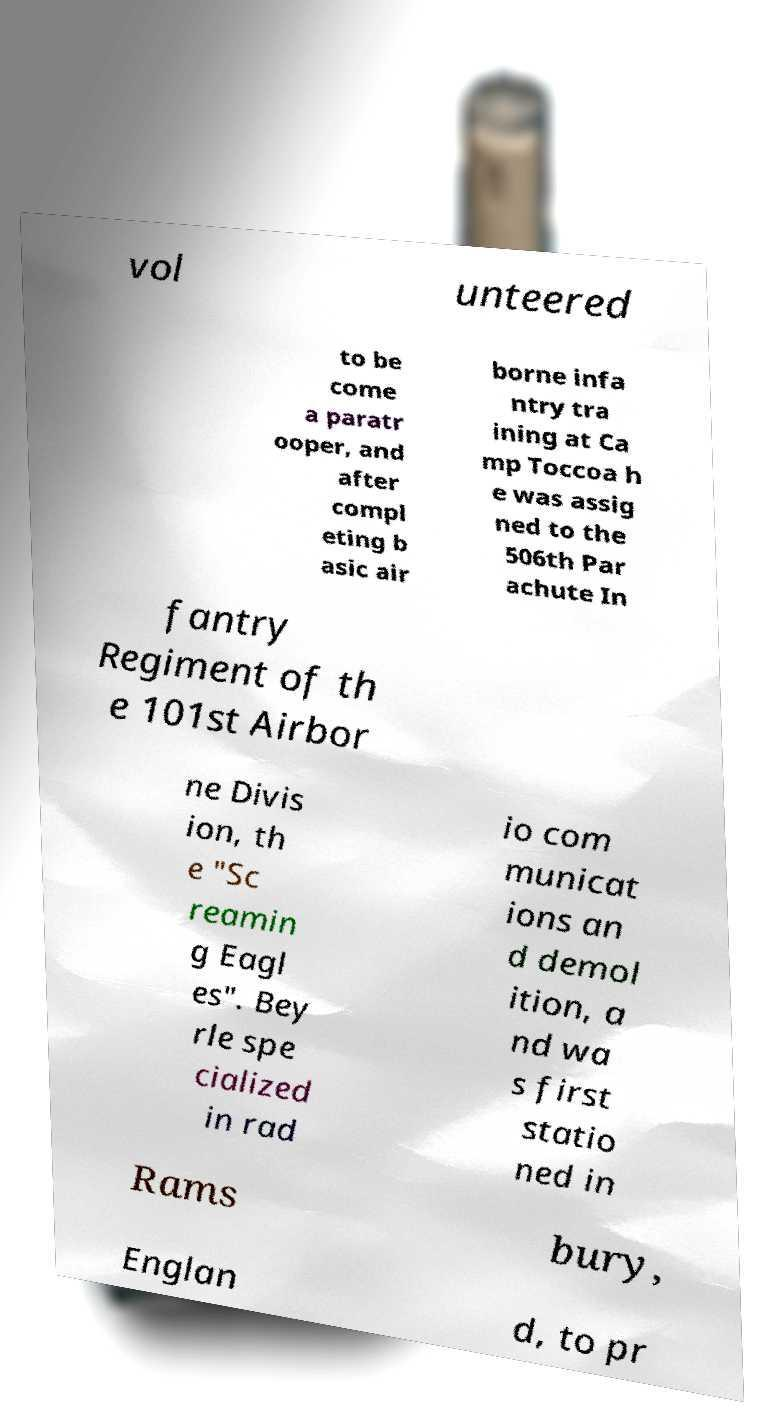Please read and relay the text visible in this image. What does it say? vol unteered to be come a paratr ooper, and after compl eting b asic air borne infa ntry tra ining at Ca mp Toccoa h e was assig ned to the 506th Par achute In fantry Regiment of th e 101st Airbor ne Divis ion, th e "Sc reamin g Eagl es". Bey rle spe cialized in rad io com municat ions an d demol ition, a nd wa s first statio ned in Rams bury, Englan d, to pr 